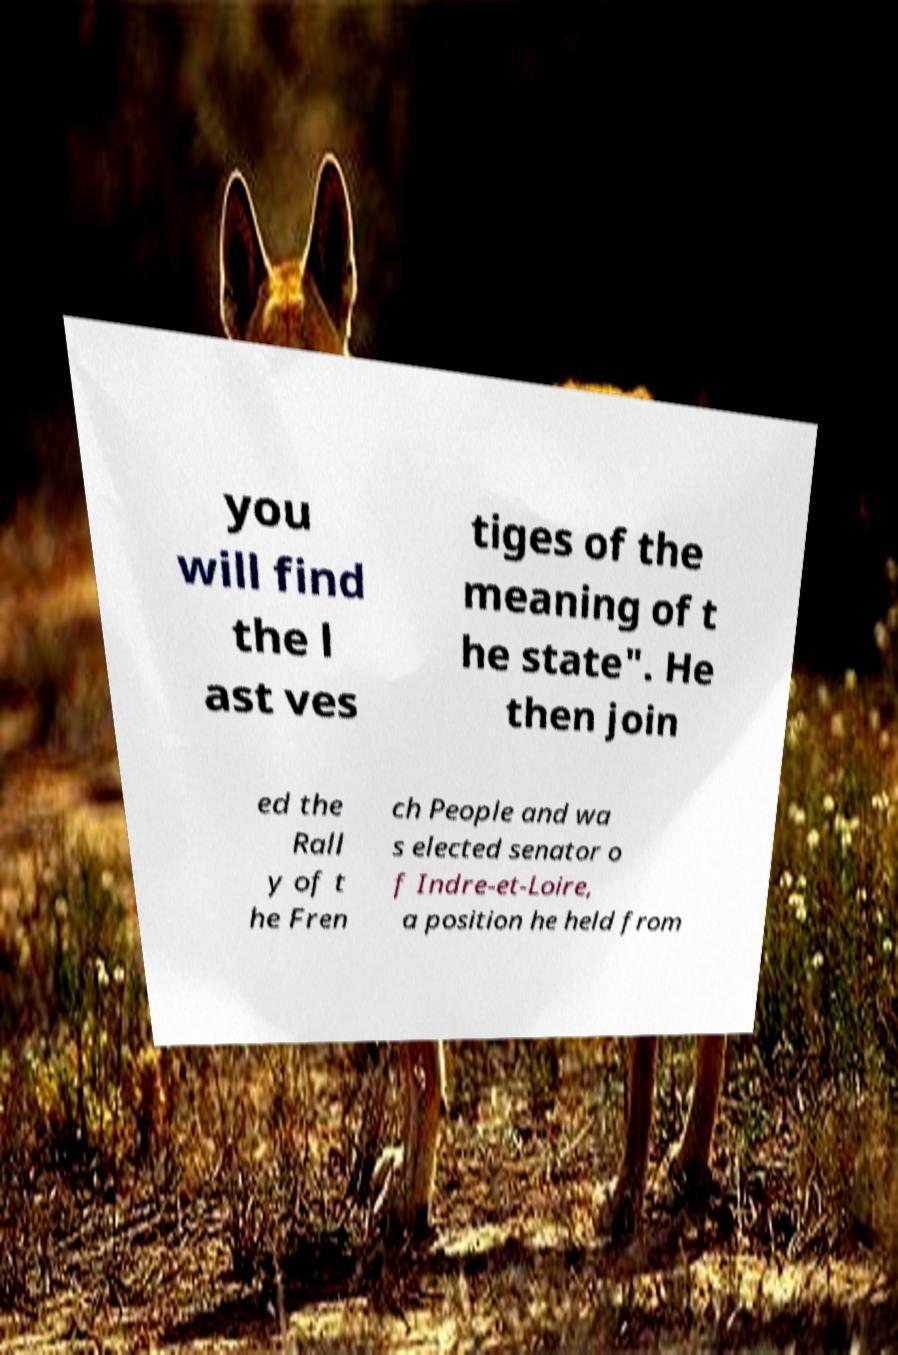I need the written content from this picture converted into text. Can you do that? you will find the l ast ves tiges of the meaning of t he state". He then join ed the Rall y of t he Fren ch People and wa s elected senator o f Indre-et-Loire, a position he held from 